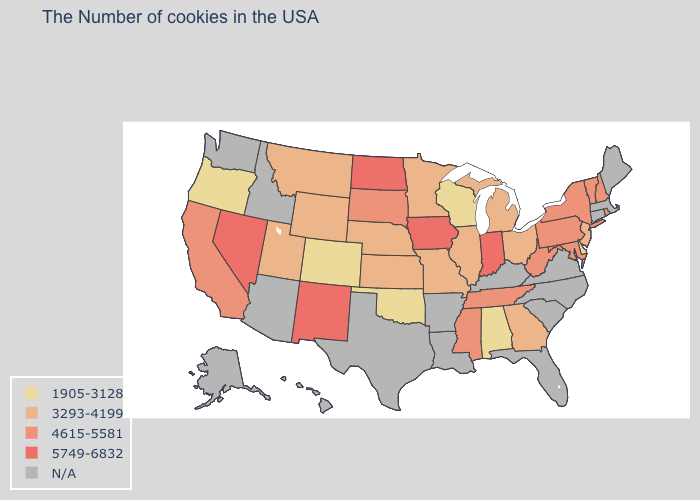What is the highest value in states that border Indiana?
Give a very brief answer. 3293-4199. What is the highest value in the West ?
Quick response, please. 5749-6832. Does the first symbol in the legend represent the smallest category?
Concise answer only. Yes. Name the states that have a value in the range 1905-3128?
Be succinct. Delaware, Alabama, Wisconsin, Oklahoma, Colorado, Oregon. Which states have the lowest value in the USA?
Give a very brief answer. Delaware, Alabama, Wisconsin, Oklahoma, Colorado, Oregon. Does Maryland have the highest value in the South?
Short answer required. Yes. What is the value of Iowa?
Be succinct. 5749-6832. What is the value of Arkansas?
Write a very short answer. N/A. How many symbols are there in the legend?
Concise answer only. 5. What is the value of Pennsylvania?
Concise answer only. 4615-5581. What is the value of Louisiana?
Short answer required. N/A. What is the value of California?
Be succinct. 4615-5581. Among the states that border South Carolina , which have the highest value?
Give a very brief answer. Georgia. Does Maryland have the lowest value in the South?
Write a very short answer. No. Which states have the highest value in the USA?
Write a very short answer. Indiana, Iowa, North Dakota, New Mexico, Nevada. 